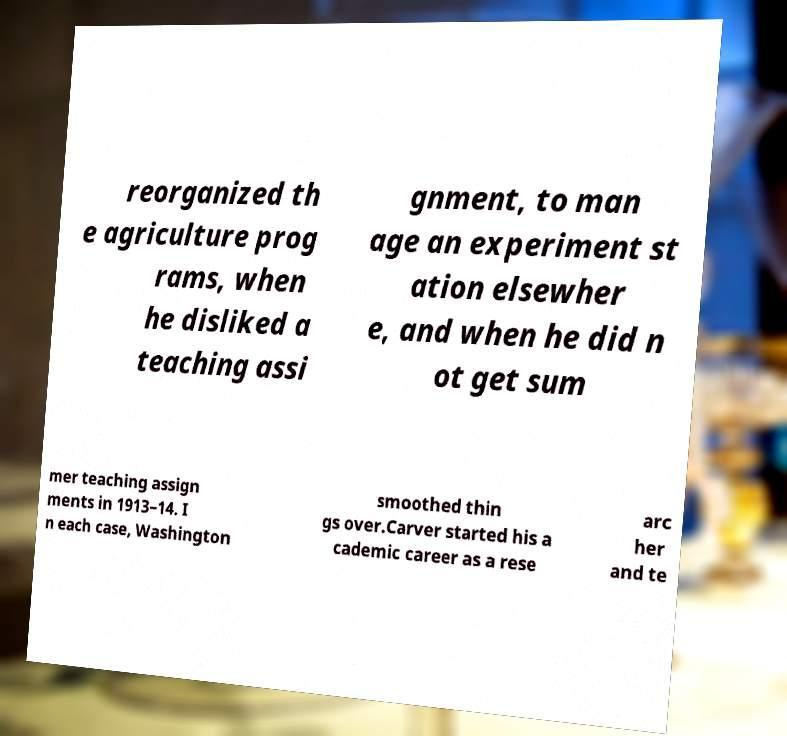I need the written content from this picture converted into text. Can you do that? reorganized th e agriculture prog rams, when he disliked a teaching assi gnment, to man age an experiment st ation elsewher e, and when he did n ot get sum mer teaching assign ments in 1913–14. I n each case, Washington smoothed thin gs over.Carver started his a cademic career as a rese arc her and te 